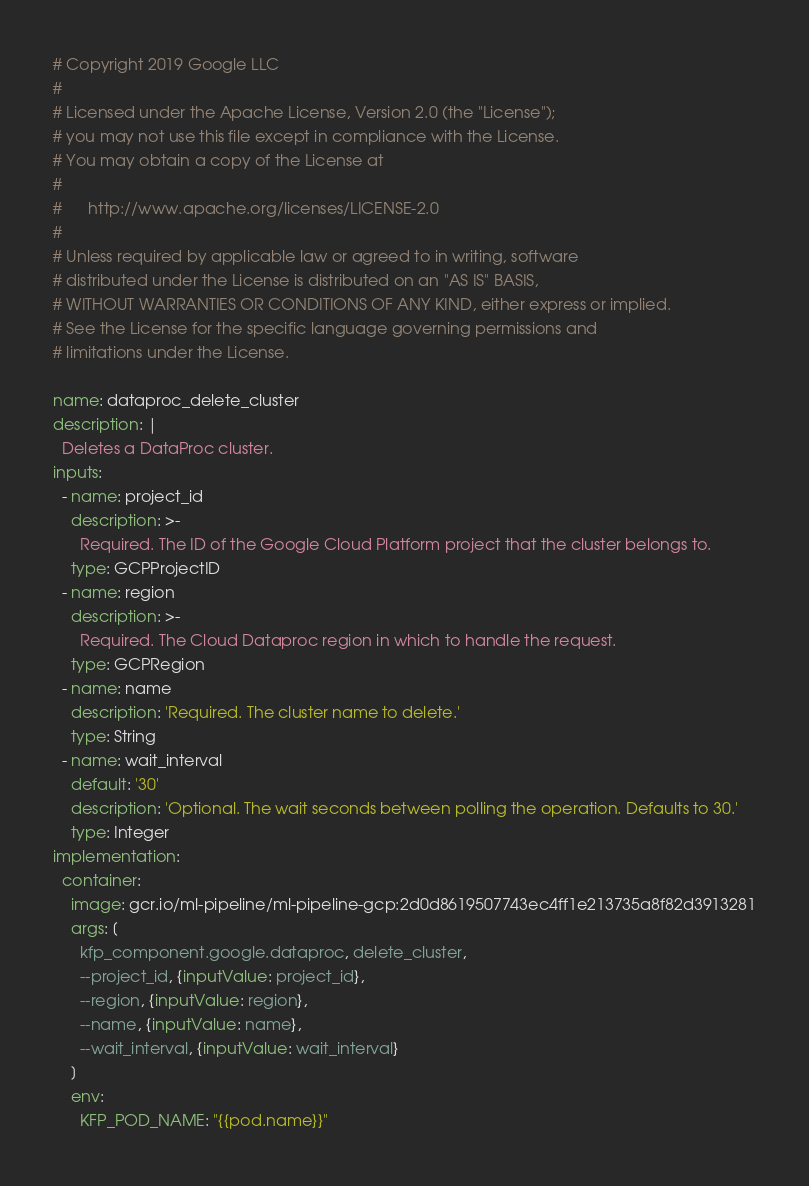<code> <loc_0><loc_0><loc_500><loc_500><_YAML_># Copyright 2019 Google LLC
#
# Licensed under the Apache License, Version 2.0 (the "License");
# you may not use this file except in compliance with the License.
# You may obtain a copy of the License at
#
#      http://www.apache.org/licenses/LICENSE-2.0
#
# Unless required by applicable law or agreed to in writing, software
# distributed under the License is distributed on an "AS IS" BASIS,
# WITHOUT WARRANTIES OR CONDITIONS OF ANY KIND, either express or implied.
# See the License for the specific language governing permissions and
# limitations under the License.

name: dataproc_delete_cluster
description: |
  Deletes a DataProc cluster.
inputs:
  - name: project_id
    description: >-
      Required. The ID of the Google Cloud Platform project that the cluster belongs to.
    type: GCPProjectID
  - name: region
    description: >-
      Required. The Cloud Dataproc region in which to handle the request.
    type: GCPRegion
  - name: name
    description: 'Required. The cluster name to delete.'
    type: String
  - name: wait_interval
    default: '30'
    description: 'Optional. The wait seconds between polling the operation. Defaults to 30.'
    type: Integer
implementation:
  container:
    image: gcr.io/ml-pipeline/ml-pipeline-gcp:2d0d8619507743ec4ff1e213735a8f82d3913281
    args: [
      kfp_component.google.dataproc, delete_cluster,
      --project_id, {inputValue: project_id},
      --region, {inputValue: region},
      --name, {inputValue: name},
      --wait_interval, {inputValue: wait_interval}
    ]
    env:
      KFP_POD_NAME: "{{pod.name}}"</code> 